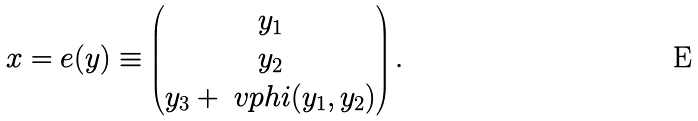Convert formula to latex. <formula><loc_0><loc_0><loc_500><loc_500>x = e ( y ) \equiv \begin{pmatrix} y _ { 1 } \\ y _ { 2 } \\ y _ { 3 } + \ v p h i ( y _ { 1 } , y _ { 2 } ) \end{pmatrix} .</formula> 